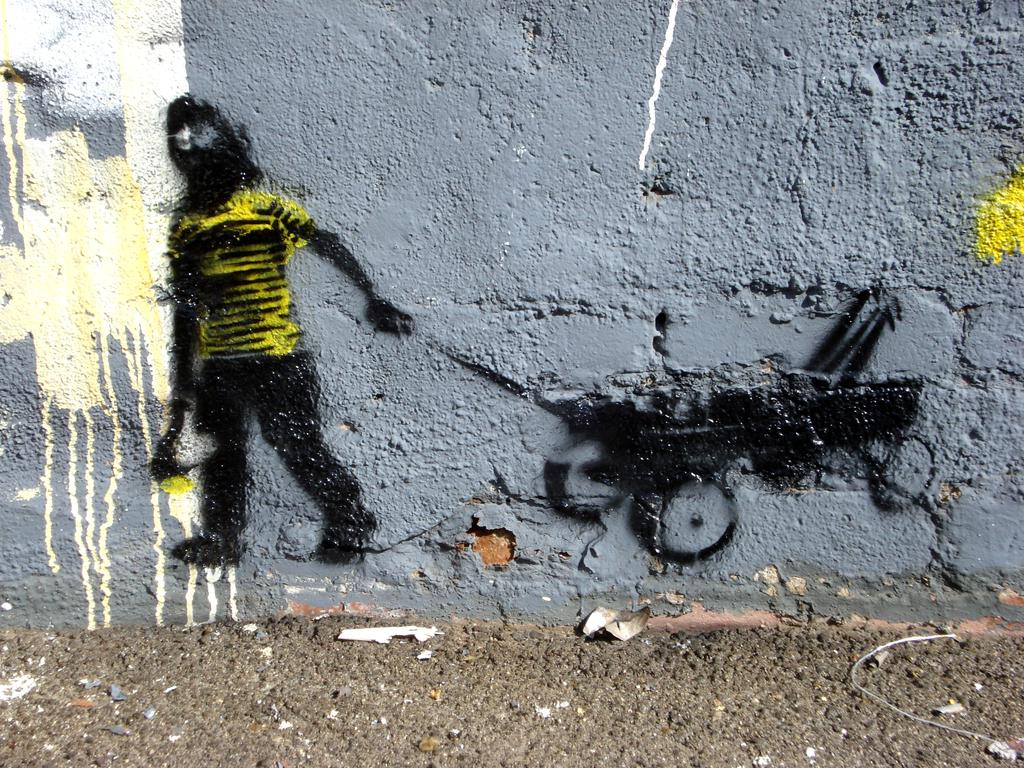What is hanging on the wall in the image? There is a painting on the wall in the image. What is located on the ground in the image? There is an iron wire on the ground in the image. Where is the crown placed in the image? There is no crown present in the image. What is the height of the place where the iron wire is located in the image? The height of the place where the iron wire is located cannot be determined from the image alone, as it only shows the wire on the ground. 